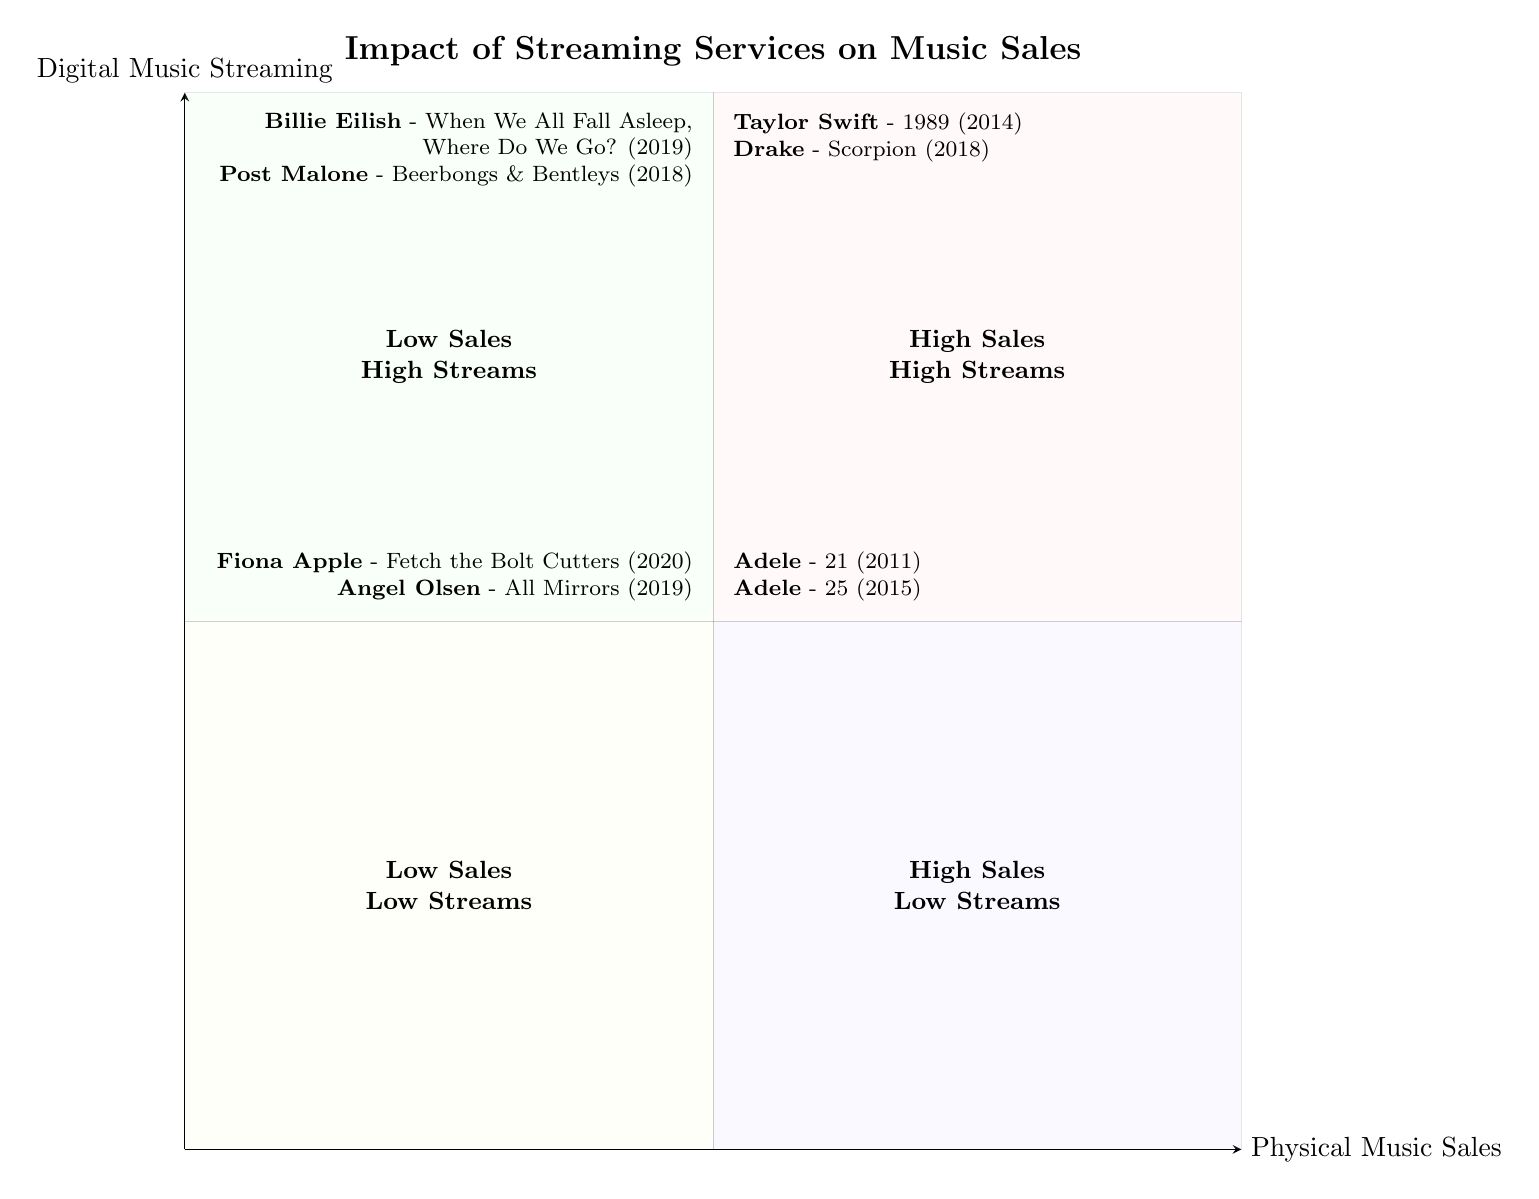What are the names of the artists in the High Sales High Streams quadrant? The High Sales High Streams quadrant includes Taylor Swift and Drake, as indicated in the diagram. Each entry lists an artist along with their respective album and release year.
Answer: Taylor Swift, Drake How many albums are listed in the Low Sales Low Streams quadrant? The Low Sales Low Streams quadrant contains two entries: Fiona Apple’s album and Angel Olsen’s album, making the total two albums.
Answer: 2 Which artist has two albums in the High Sales Low Streams quadrant? The diagram shows Adele with two albums, "21" and "25," located in the High Sales Low Streams quadrant, indicating her significant physical sales despite lower streaming numbers.
Answer: Adele What is the release year of the album "Scorpion"? The album "Scorpion" by Drake, found in the High Sales High Streams quadrant, has the release year clearly indicated as 2018.
Answer: 2018 Which quadrant contains the album "When We All Fall Asleep, Where Do We Go?" The album by Billie Eilish is categorized in the Low Sales High Streams quadrant, which includes artists and albums that have high streaming but lower physical sales.
Answer: Low Sales High Streams How many total unique artists are represented in the Low Sales High Streams quadrant? The Low Sales High Streams quadrant lists two different artists: Billie Eilish and Post Malone, thus the total number of unique artists in that quadrant is two.
Answer: 2 Which albums from the High Sales Low Streams quadrant were released earlier? Among the albums listed in the High Sales Low Streams quadrant, Adele's "21" (2011) is earlier than "25" (2015), indicating both were successful in physical sales but had lower streaming numbers.
Answer: 21 What is the main observation regarding streaming and sales for Billie Eilish and Post Malone? Both artists are located in the Low Sales High Streams quadrant, indicating they achieved high streaming numbers while experiencing low physical sales, reflecting a trend among newer artists.
Answer: High streams, low sales Which artist from the High Sales High Streams quadrant has the most recent album listed? Drake's album "Scorpion" (2018) is the most recent compared to Taylor Swift's "1989" (2014), making Drake the artist with the latest album in the High Sales High Streams quadrant.
Answer: Drake 